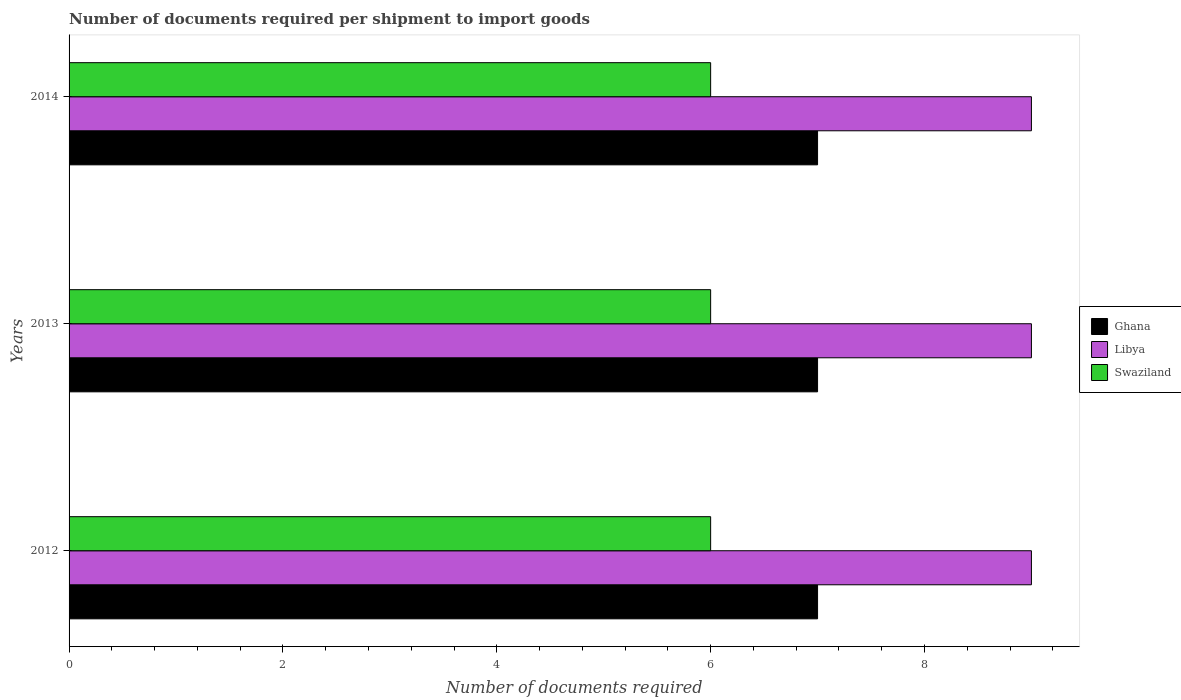Are the number of bars per tick equal to the number of legend labels?
Make the answer very short. Yes. Are the number of bars on each tick of the Y-axis equal?
Provide a succinct answer. Yes. What is the label of the 1st group of bars from the top?
Ensure brevity in your answer.  2014. What is the number of documents required per shipment to import goods in Ghana in 2014?
Keep it short and to the point. 7. Across all years, what is the minimum number of documents required per shipment to import goods in Swaziland?
Keep it short and to the point. 6. What is the total number of documents required per shipment to import goods in Ghana in the graph?
Offer a terse response. 21. What is the difference between the number of documents required per shipment to import goods in Swaziland in 2014 and the number of documents required per shipment to import goods in Ghana in 2013?
Offer a terse response. -1. In the year 2014, what is the difference between the number of documents required per shipment to import goods in Swaziland and number of documents required per shipment to import goods in Ghana?
Your answer should be very brief. -1. In how many years, is the number of documents required per shipment to import goods in Ghana greater than 0.4 ?
Your response must be concise. 3. What is the ratio of the number of documents required per shipment to import goods in Libya in 2012 to that in 2013?
Ensure brevity in your answer.  1. Is the difference between the number of documents required per shipment to import goods in Swaziland in 2013 and 2014 greater than the difference between the number of documents required per shipment to import goods in Ghana in 2013 and 2014?
Your response must be concise. No. What is the difference between the highest and the second highest number of documents required per shipment to import goods in Ghana?
Provide a succinct answer. 0. What is the difference between the highest and the lowest number of documents required per shipment to import goods in Ghana?
Offer a very short reply. 0. Is the sum of the number of documents required per shipment to import goods in Libya in 2013 and 2014 greater than the maximum number of documents required per shipment to import goods in Swaziland across all years?
Make the answer very short. Yes. What does the 1st bar from the top in 2013 represents?
Your answer should be compact. Swaziland. How many bars are there?
Your answer should be compact. 9. Are all the bars in the graph horizontal?
Your answer should be very brief. Yes. What is the difference between two consecutive major ticks on the X-axis?
Make the answer very short. 2. Where does the legend appear in the graph?
Keep it short and to the point. Center right. How many legend labels are there?
Make the answer very short. 3. How are the legend labels stacked?
Your answer should be compact. Vertical. What is the title of the graph?
Your response must be concise. Number of documents required per shipment to import goods. What is the label or title of the X-axis?
Your response must be concise. Number of documents required. What is the label or title of the Y-axis?
Your answer should be compact. Years. What is the Number of documents required of Libya in 2012?
Provide a succinct answer. 9. What is the Number of documents required of Swaziland in 2012?
Your answer should be compact. 6. What is the Number of documents required in Libya in 2013?
Provide a short and direct response. 9. Across all years, what is the maximum Number of documents required in Ghana?
Provide a short and direct response. 7. Across all years, what is the maximum Number of documents required of Swaziland?
Keep it short and to the point. 6. Across all years, what is the minimum Number of documents required of Swaziland?
Offer a very short reply. 6. What is the total Number of documents required of Libya in the graph?
Your response must be concise. 27. What is the total Number of documents required in Swaziland in the graph?
Offer a terse response. 18. What is the difference between the Number of documents required in Ghana in 2012 and that in 2013?
Make the answer very short. 0. What is the difference between the Number of documents required of Libya in 2012 and that in 2013?
Provide a succinct answer. 0. What is the difference between the Number of documents required of Swaziland in 2012 and that in 2013?
Offer a very short reply. 0. What is the difference between the Number of documents required in Libya in 2012 and that in 2014?
Your answer should be compact. 0. What is the difference between the Number of documents required in Swaziland in 2013 and that in 2014?
Keep it short and to the point. 0. What is the difference between the Number of documents required in Ghana in 2012 and the Number of documents required in Libya in 2013?
Provide a short and direct response. -2. What is the difference between the Number of documents required in Ghana in 2012 and the Number of documents required in Swaziland in 2013?
Give a very brief answer. 1. What is the difference between the Number of documents required in Libya in 2012 and the Number of documents required in Swaziland in 2013?
Make the answer very short. 3. What is the difference between the Number of documents required of Ghana in 2012 and the Number of documents required of Swaziland in 2014?
Ensure brevity in your answer.  1. What is the difference between the Number of documents required in Ghana in 2013 and the Number of documents required in Libya in 2014?
Your answer should be very brief. -2. What is the difference between the Number of documents required in Ghana in 2013 and the Number of documents required in Swaziland in 2014?
Offer a terse response. 1. What is the average Number of documents required in Swaziland per year?
Provide a short and direct response. 6. In the year 2012, what is the difference between the Number of documents required of Libya and Number of documents required of Swaziland?
Ensure brevity in your answer.  3. In the year 2013, what is the difference between the Number of documents required of Libya and Number of documents required of Swaziland?
Provide a succinct answer. 3. In the year 2014, what is the difference between the Number of documents required of Ghana and Number of documents required of Libya?
Your answer should be very brief. -2. In the year 2014, what is the difference between the Number of documents required of Ghana and Number of documents required of Swaziland?
Your answer should be compact. 1. In the year 2014, what is the difference between the Number of documents required in Libya and Number of documents required in Swaziland?
Give a very brief answer. 3. What is the ratio of the Number of documents required of Ghana in 2012 to that in 2013?
Ensure brevity in your answer.  1. What is the ratio of the Number of documents required in Ghana in 2012 to that in 2014?
Your response must be concise. 1. What is the ratio of the Number of documents required in Libya in 2012 to that in 2014?
Offer a terse response. 1. What is the ratio of the Number of documents required in Swaziland in 2013 to that in 2014?
Provide a short and direct response. 1. What is the difference between the highest and the second highest Number of documents required in Ghana?
Keep it short and to the point. 0. What is the difference between the highest and the second highest Number of documents required of Libya?
Give a very brief answer. 0. What is the difference between the highest and the lowest Number of documents required in Ghana?
Ensure brevity in your answer.  0. What is the difference between the highest and the lowest Number of documents required in Libya?
Give a very brief answer. 0. What is the difference between the highest and the lowest Number of documents required in Swaziland?
Give a very brief answer. 0. 